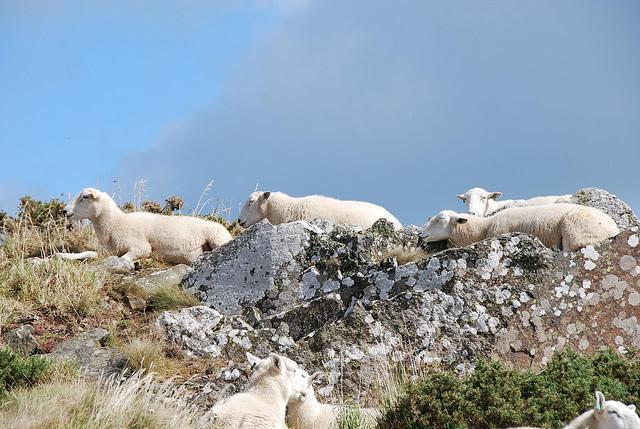What are the animals doing on the hill?
Choose the correct response and explain in the format: 'Answer: answer
Rationale: rationale.'
Options: Mating, eating, fighting, sitting. Answer: sitting.
Rationale: The animals have their legs out in front of them as they relax in the sun 